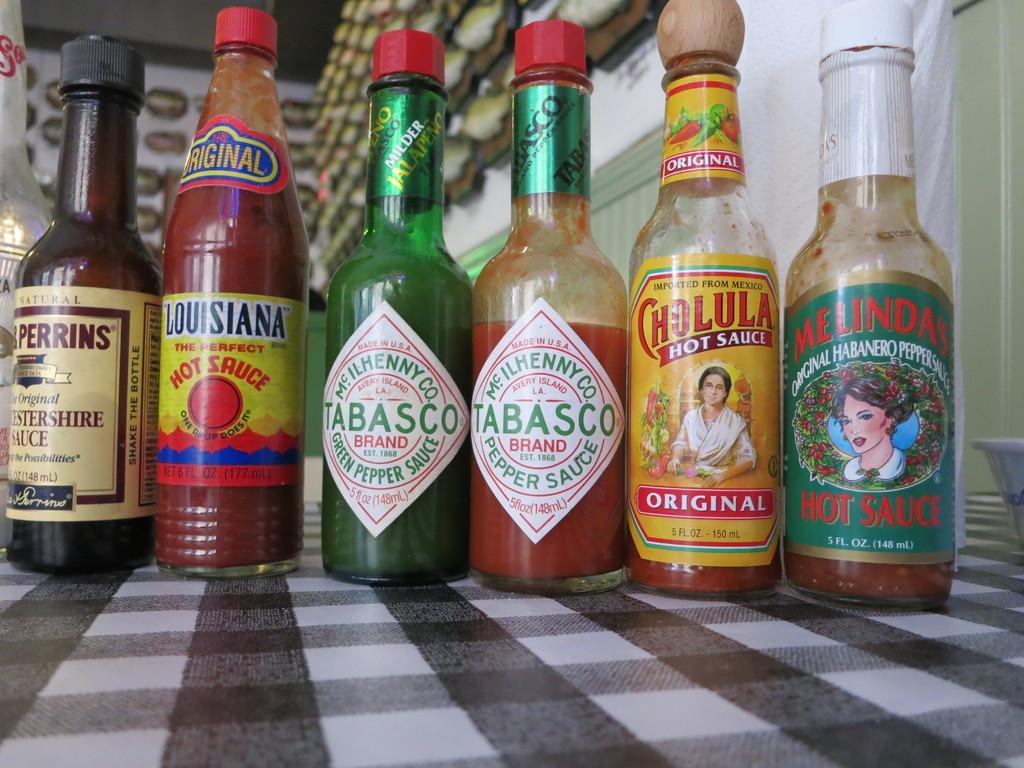Describe this image in one or two sentences. In this image there are six bottles and these bottles are filled with sauce. On the right side of the top corner there is one wall and on the bottom of the right corner there is one bowl, on the background of the image there are some wall art. 